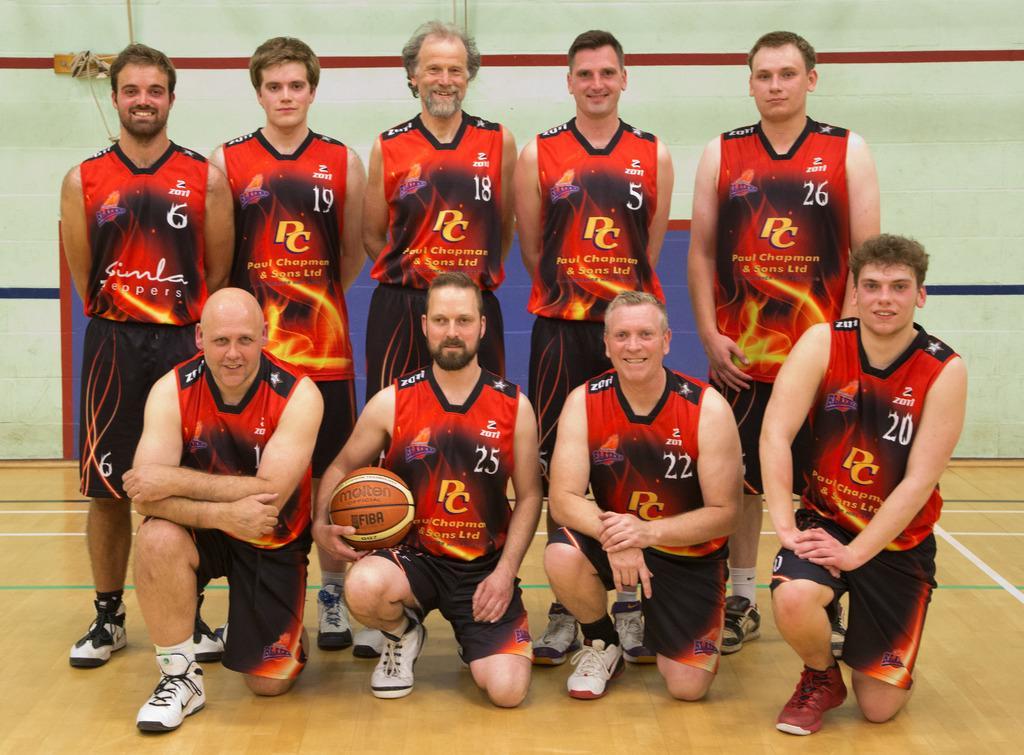Describe this image in one or two sentences. Here we can see few persons are posing to a camera and they are smiling. He is holding a ball with his hand. This is floor. In the background there is a wall. 